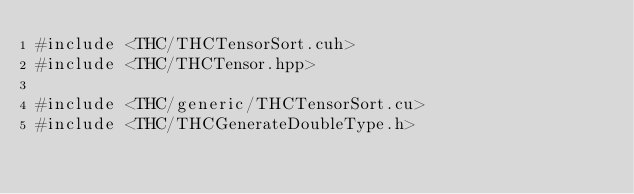Convert code to text. <code><loc_0><loc_0><loc_500><loc_500><_Cuda_>#include <THC/THCTensorSort.cuh>
#include <THC/THCTensor.hpp>

#include <THC/generic/THCTensorSort.cu>
#include <THC/THCGenerateDoubleType.h>
</code> 